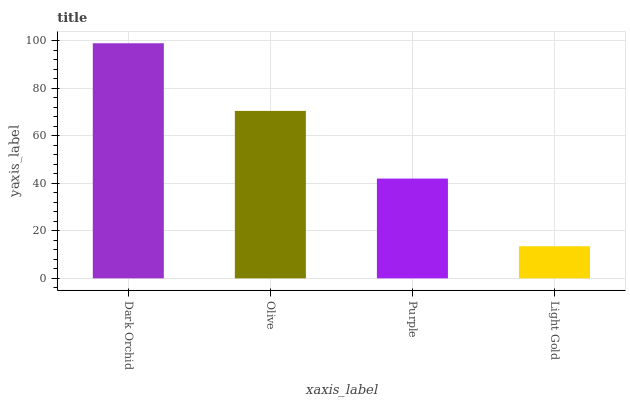Is Olive the minimum?
Answer yes or no. No. Is Olive the maximum?
Answer yes or no. No. Is Dark Orchid greater than Olive?
Answer yes or no. Yes. Is Olive less than Dark Orchid?
Answer yes or no. Yes. Is Olive greater than Dark Orchid?
Answer yes or no. No. Is Dark Orchid less than Olive?
Answer yes or no. No. Is Olive the high median?
Answer yes or no. Yes. Is Purple the low median?
Answer yes or no. Yes. Is Dark Orchid the high median?
Answer yes or no. No. Is Dark Orchid the low median?
Answer yes or no. No. 